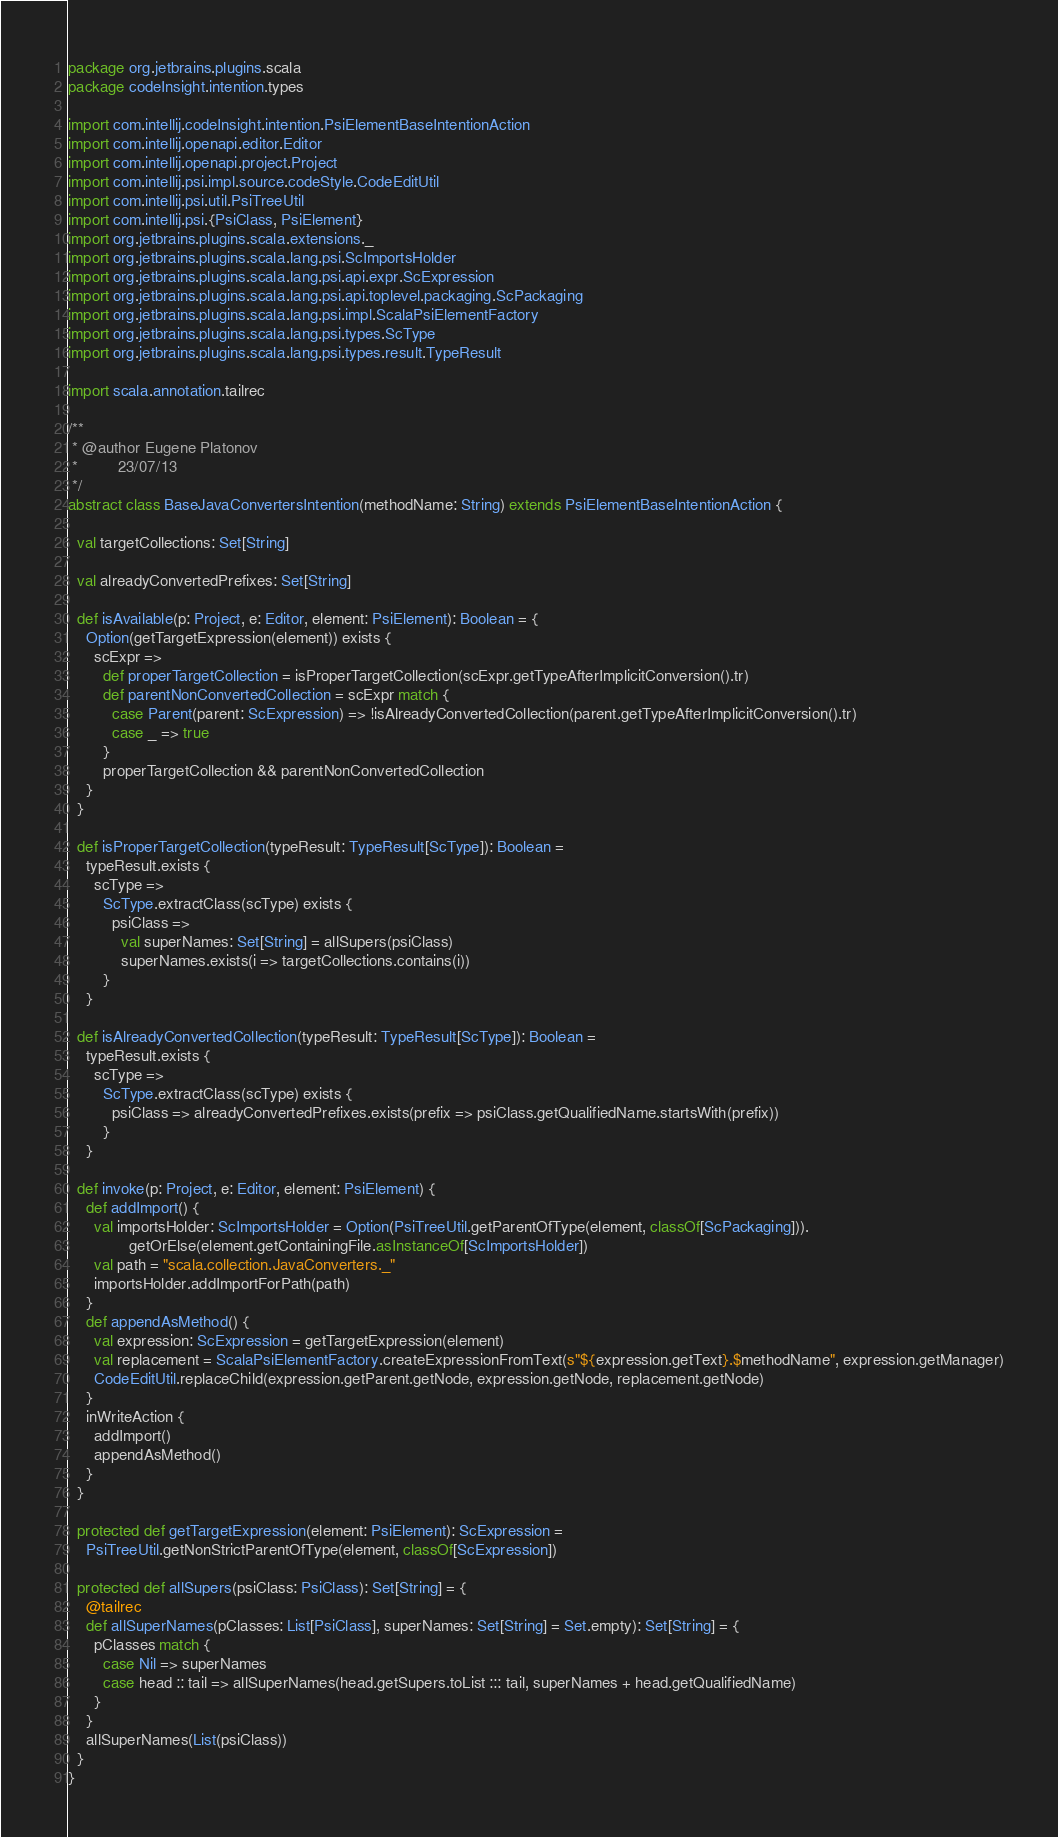<code> <loc_0><loc_0><loc_500><loc_500><_Scala_>package org.jetbrains.plugins.scala
package codeInsight.intention.types

import com.intellij.codeInsight.intention.PsiElementBaseIntentionAction
import com.intellij.openapi.editor.Editor
import com.intellij.openapi.project.Project
import com.intellij.psi.impl.source.codeStyle.CodeEditUtil
import com.intellij.psi.util.PsiTreeUtil
import com.intellij.psi.{PsiClass, PsiElement}
import org.jetbrains.plugins.scala.extensions._
import org.jetbrains.plugins.scala.lang.psi.ScImportsHolder
import org.jetbrains.plugins.scala.lang.psi.api.expr.ScExpression
import org.jetbrains.plugins.scala.lang.psi.api.toplevel.packaging.ScPackaging
import org.jetbrains.plugins.scala.lang.psi.impl.ScalaPsiElementFactory
import org.jetbrains.plugins.scala.lang.psi.types.ScType
import org.jetbrains.plugins.scala.lang.psi.types.result.TypeResult

import scala.annotation.tailrec

/**
 * @author Eugene Platonov
 *         23/07/13
 */
abstract class BaseJavaConvertersIntention(methodName: String) extends PsiElementBaseIntentionAction {

  val targetCollections: Set[String]

  val alreadyConvertedPrefixes: Set[String]

  def isAvailable(p: Project, e: Editor, element: PsiElement): Boolean = {
    Option(getTargetExpression(element)) exists {
      scExpr =>
        def properTargetCollection = isProperTargetCollection(scExpr.getTypeAfterImplicitConversion().tr)
        def parentNonConvertedCollection = scExpr match {
          case Parent(parent: ScExpression) => !isAlreadyConvertedCollection(parent.getTypeAfterImplicitConversion().tr)
          case _ => true
        }
        properTargetCollection && parentNonConvertedCollection
    }
  }

  def isProperTargetCollection(typeResult: TypeResult[ScType]): Boolean =
    typeResult.exists {
      scType =>
        ScType.extractClass(scType) exists {
          psiClass =>
            val superNames: Set[String] = allSupers(psiClass)
            superNames.exists(i => targetCollections.contains(i))
        }
    }

  def isAlreadyConvertedCollection(typeResult: TypeResult[ScType]): Boolean =
    typeResult.exists {
      scType =>
        ScType.extractClass(scType) exists {
          psiClass => alreadyConvertedPrefixes.exists(prefix => psiClass.getQualifiedName.startsWith(prefix))
        }
    }

  def invoke(p: Project, e: Editor, element: PsiElement) {
    def addImport() {
      val importsHolder: ScImportsHolder = Option(PsiTreeUtil.getParentOfType(element, classOf[ScPackaging])).
              getOrElse(element.getContainingFile.asInstanceOf[ScImportsHolder])
      val path = "scala.collection.JavaConverters._"
      importsHolder.addImportForPath(path)
    }
    def appendAsMethod() {
      val expression: ScExpression = getTargetExpression(element)
      val replacement = ScalaPsiElementFactory.createExpressionFromText(s"${expression.getText}.$methodName", expression.getManager)
      CodeEditUtil.replaceChild(expression.getParent.getNode, expression.getNode, replacement.getNode)
    }
    inWriteAction {
      addImport()
      appendAsMethod()
    }
  }

  protected def getTargetExpression(element: PsiElement): ScExpression =
    PsiTreeUtil.getNonStrictParentOfType(element, classOf[ScExpression])

  protected def allSupers(psiClass: PsiClass): Set[String] = {
    @tailrec
    def allSuperNames(pClasses: List[PsiClass], superNames: Set[String] = Set.empty): Set[String] = {
      pClasses match {
        case Nil => superNames
        case head :: tail => allSuperNames(head.getSupers.toList ::: tail, superNames + head.getQualifiedName)
      }
    }
    allSuperNames(List(psiClass))
  }
}
</code> 